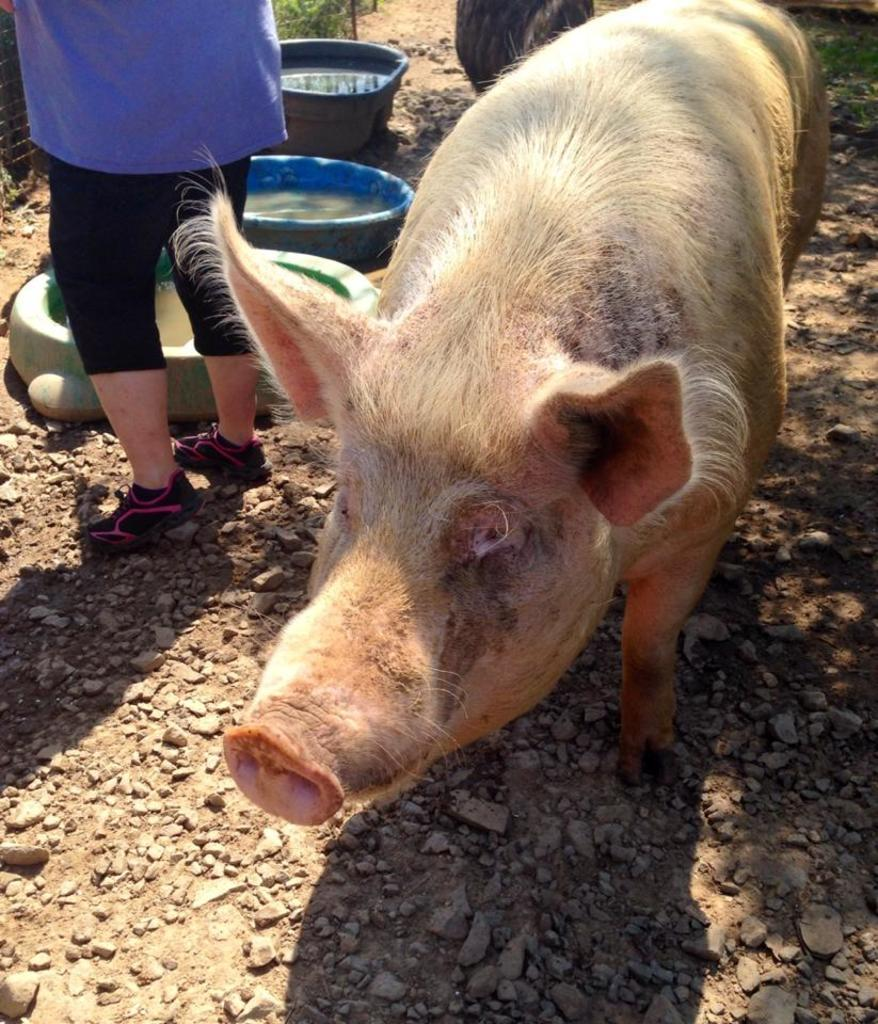What is the main subject in the center of the image? There is a pig in the center of the image. Who or what is on the left side of the image? There is a person on the left side of the image. What type of containers can be seen in the image? There are tubs visible in the image. What can be seen at the bottom of the image? The ground is visible at the bottom of the image. What type of squirrel can be seen running down the alley in the image? There is no squirrel or alley present in the image. Is there a railway visible in the image? There is no railway present in the image. 